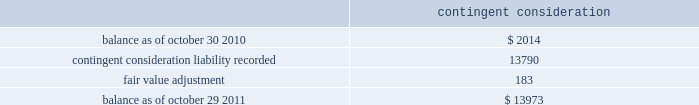( 2 ) the company has a master netting arrangement by counterparty with respect to derivative contracts .
As of october 29 , 2011 and october 30 , 2010 , contracts in a liability position of $ 0.8 million in each year , were netted against contracts in an asset position in the consolidated balance sheets .
( 3 ) equal to the accreted notional value of the debt plus the fair value of the interest rate component of the long- term debt .
The fair value of the long-term debt as of october 29 , 2011 and october 30 , 2010 was $ 413.4 million and $ 416.3 million , respectively .
The following methods and assumptions were used by the company in estimating its fair value disclosures for financial instruments : cash equivalents and short-term investments 2014 these investments are adjusted to fair value based on quoted market prices or are determined using a yield curve model based on current market rates .
Deferred compensation plan investments and other investments 2014 the fair value of these mutual fund , money market fund and equity investments are based on quoted market prices .
Long-term debt 2014 the fair value of long-term debt is based on quotes received from third-party banks .
Interest rate swap agreements 2014 the fair value of interest rate swap agreements is based on quotes received from third-party banks .
These values represent the estimated amount the company would receive or pay to terminate the agreements taking into consideration current interest rates as well as the creditworthiness of the counterparty .
Forward foreign currency exchange contracts 2014 the estimated fair value of forward foreign currency exchange contracts , which includes derivatives that are accounted for as cash flow hedges and those that are not designated as cash flow hedges , is based on the estimated amount the company would receive if it sold these agreements at the reporting date taking into consideration current interest rates as well as the creditworthiness of the counterparty for assets and the company 2019s creditworthiness for liabilities .
Contingent consideration 2014 the fair value of contingent consideration was estimated utilizing the income approach and is based upon significant inputs not observable in the market .
Changes in the fair value of the contingent consideration subsequent to the acquisition date that are primarily driven by assumptions pertaining to the achievement of the defined milestones will be recognized in operating income in the period of the estimated fair value change .
The table summarizes the change in the fair value of the contingent consideration measured using significant unobservable inputs ( level 3 ) for fiscal 2011 : contingent consideration .
Financial instruments not recorded at fair value on a recurring basis on april 4 , 2011 , the company issued $ 375 million aggregate principal amount of 3.0% ( 3.0 % ) senior unsecured notes due april 15 , 2016 ( the 3.0% ( 3.0 % ) notes ) with semi-annual fixed interest payments due on april 15 and october 15 of each year , commencing october 15 , 2011 .
The fair value of the 3.0% ( 3.0 % ) notes as of october 29 , 2011 was $ 392.8 million , based on quotes received from third-party banks .
Analog devices , inc .
Notes to consolidated financial statements 2014 ( continued ) .
What is the interest payment of the 3.0% ( 3.0 % ) notes? 
Computations: ((375 * 3.0%) / 2)
Answer: 5.625. 